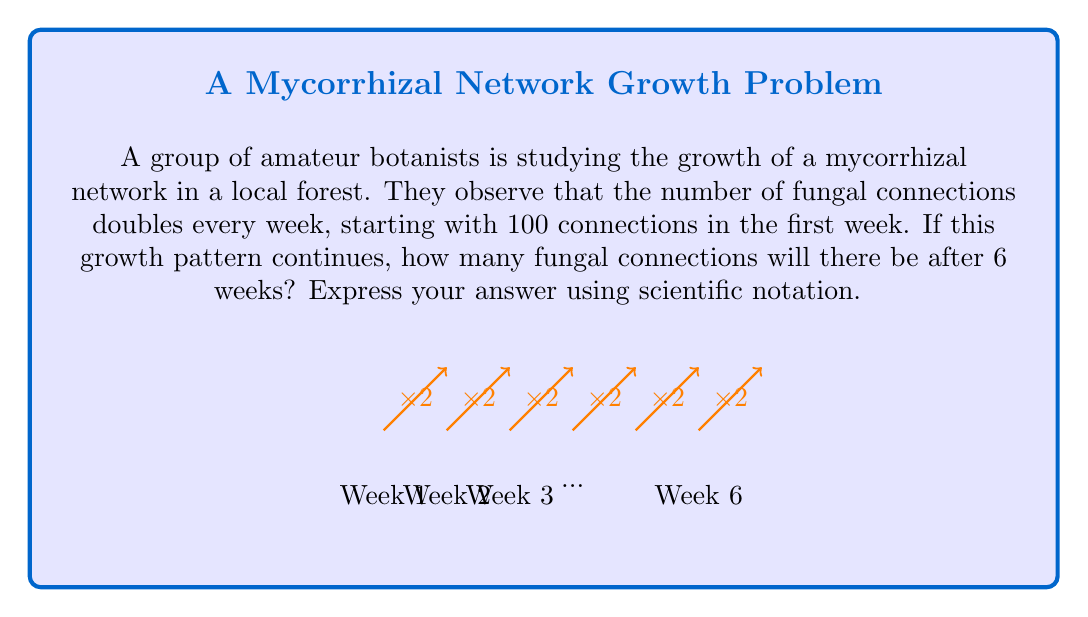Help me with this question. Let's approach this step-by-step using a discrete time model:

1) We start with 100 connections in week 1.

2) The growth can be modeled by the exponential function:
   $f(t) = 100 \cdot 2^{t-1}$, where $t$ is the number of weeks.

3) We want to find $f(6)$:
   $f(6) = 100 \cdot 2^{6-1} = 100 \cdot 2^5$

4) Let's calculate this:
   $100 \cdot 2^5 = 100 \cdot 32 = 3200$

5) To express this in scientific notation:
   $3200 = 3.2 \times 10^3$

Therefore, after 6 weeks, there will be $3.2 \times 10^3$ fungal connections.
Answer: $3.2 \times 10^3$ 